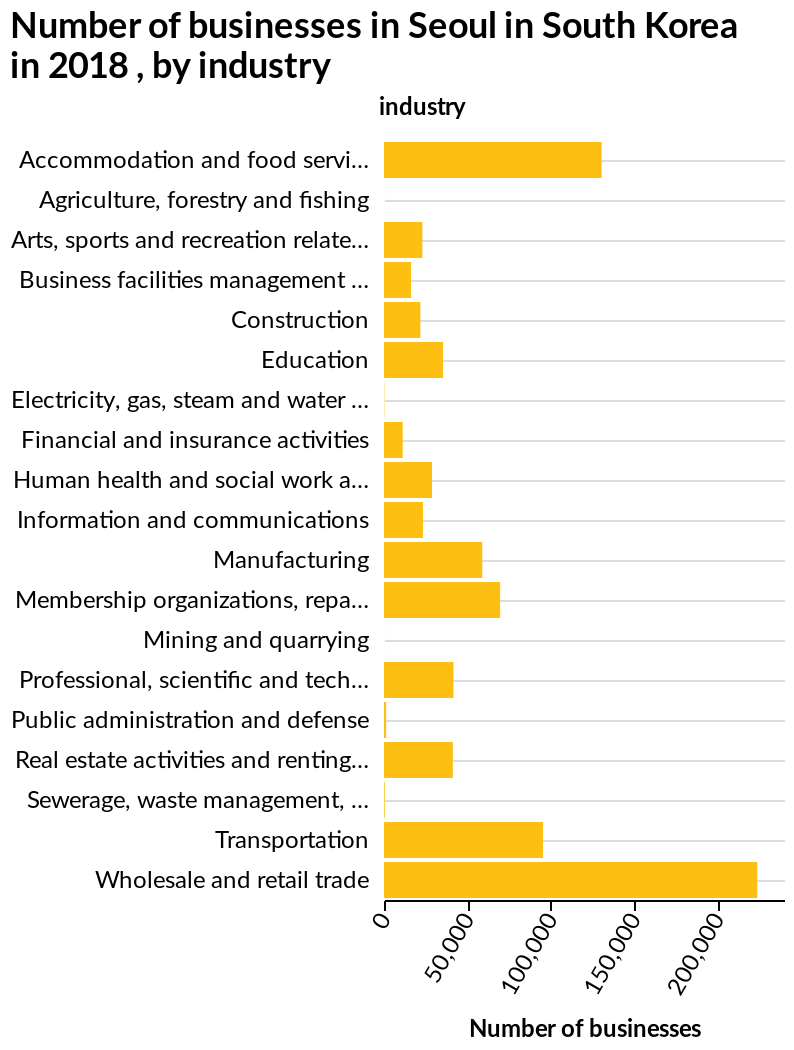<image>
please summary the statistics and relations of the chart The biggest industry in Seoul, South Korea in 2018 was the wholesale and retail trade.The second largest industry was accommodation and food services. In what year was the wholesale and retail trade the biggest industry in Seoul?  The wholesale and retail trade was the biggest industry in Seoul in 2018. 